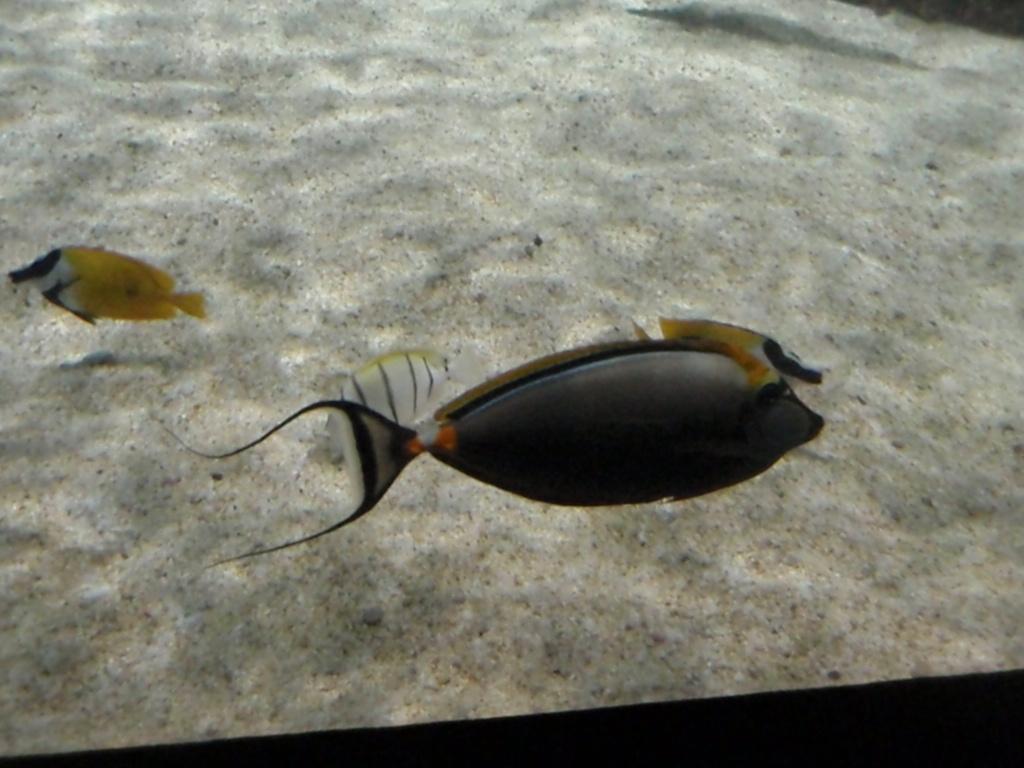Can you describe this image briefly? As we can see in the image there is water, sand and fishes. 